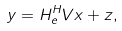Convert formula to latex. <formula><loc_0><loc_0><loc_500><loc_500>y = H _ { e } ^ { H } V x + z ,</formula> 